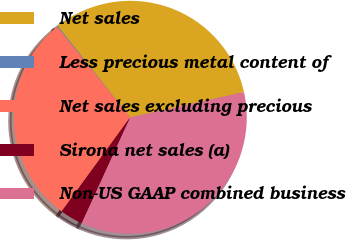Convert chart. <chart><loc_0><loc_0><loc_500><loc_500><pie_chart><fcel>Net sales<fcel>Less precious metal content of<fcel>Net sales excluding precious<fcel>Sirona net sales (a)<fcel>Non-US GAAP combined business<nl><fcel>32.23%<fcel>0.12%<fcel>29.17%<fcel>3.18%<fcel>35.3%<nl></chart> 